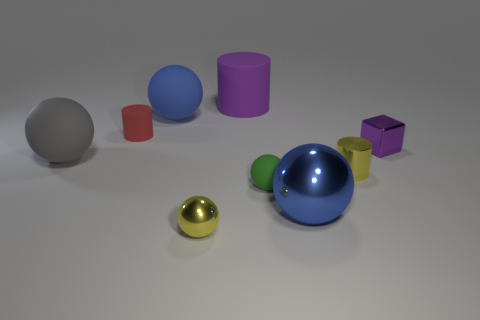What is the relative arrangement of the objects, and does it suggest anything about their interaction? The objects are arranged in a seemingly random scatter, with varying distances between them. There is no obvious pattern or interaction, which suggests a non-functional arrangement, possibly intended for a display or to evaluate their visual qualities in relation to one another. 